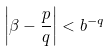Convert formula to latex. <formula><loc_0><loc_0><loc_500><loc_500>\left | \beta - \frac { p } { q } \right | < b ^ { - q }</formula> 